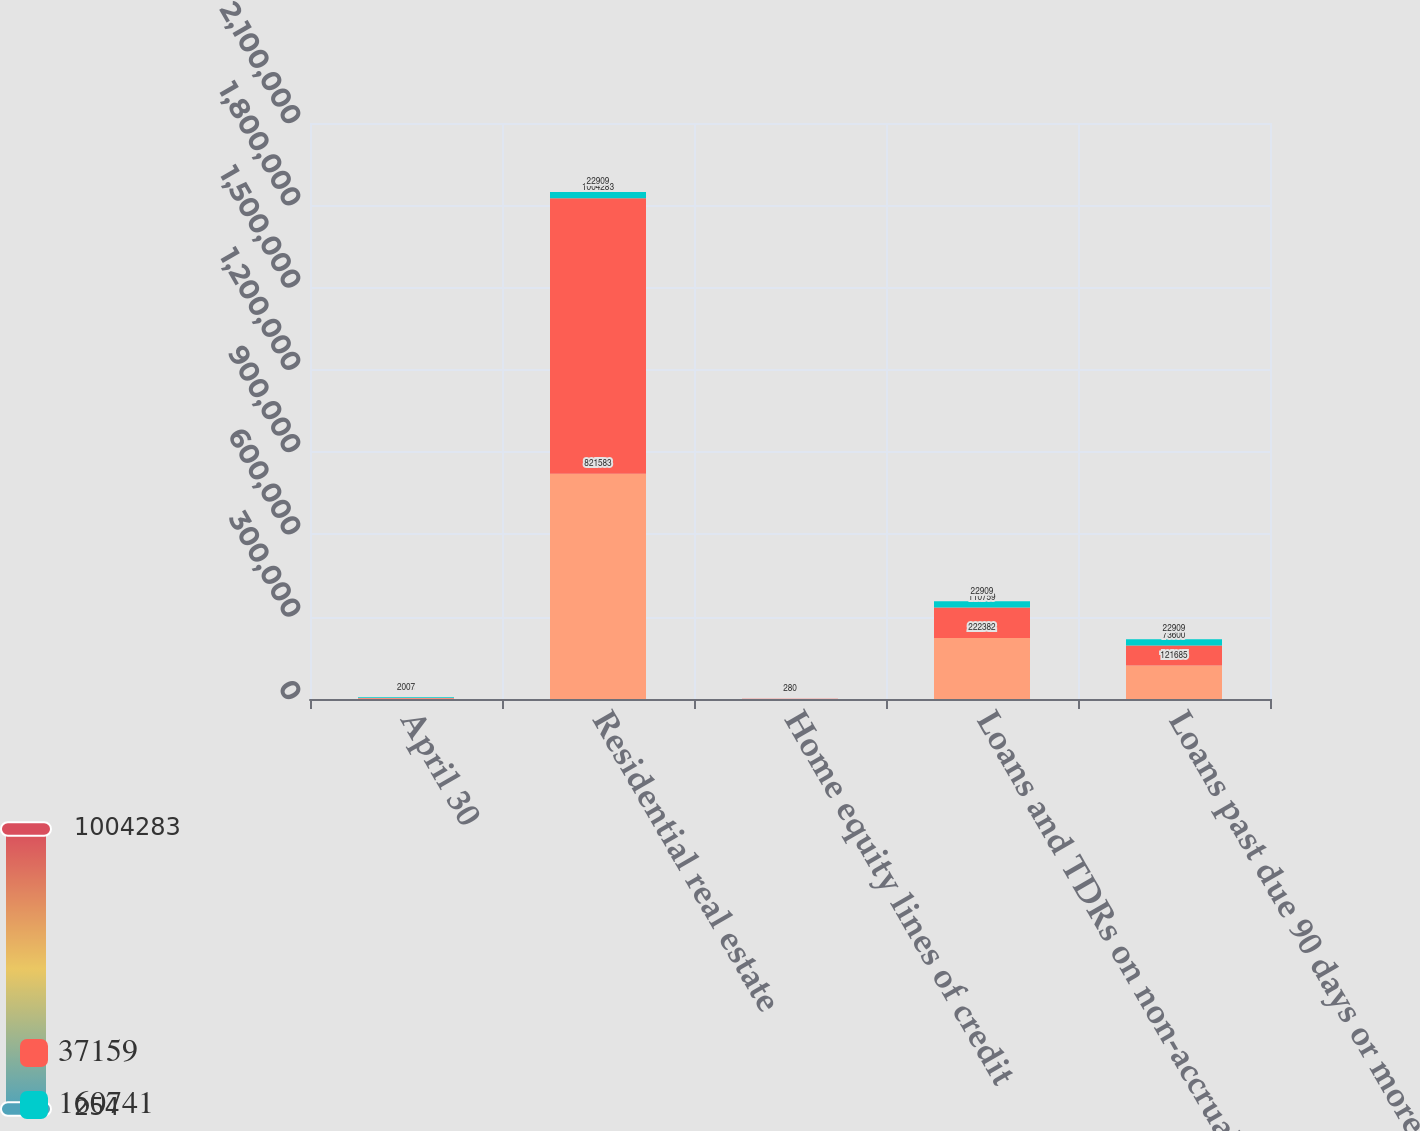Convert chart to OTSL. <chart><loc_0><loc_0><loc_500><loc_500><stacked_bar_chart><ecel><fcel>April 30<fcel>Residential real estate<fcel>Home equity lines of credit<fcel>Loans and TDRs on non-accrual<fcel>Loans past due 90 days or more<nl><fcel>nan<fcel>2009<fcel>821583<fcel>254<fcel>222382<fcel>121685<nl><fcel>37159<fcel>2008<fcel>1.00428e+06<fcel>357<fcel>110759<fcel>73600<nl><fcel>160741<fcel>2007<fcel>22909<fcel>280<fcel>22909<fcel>22909<nl></chart> 